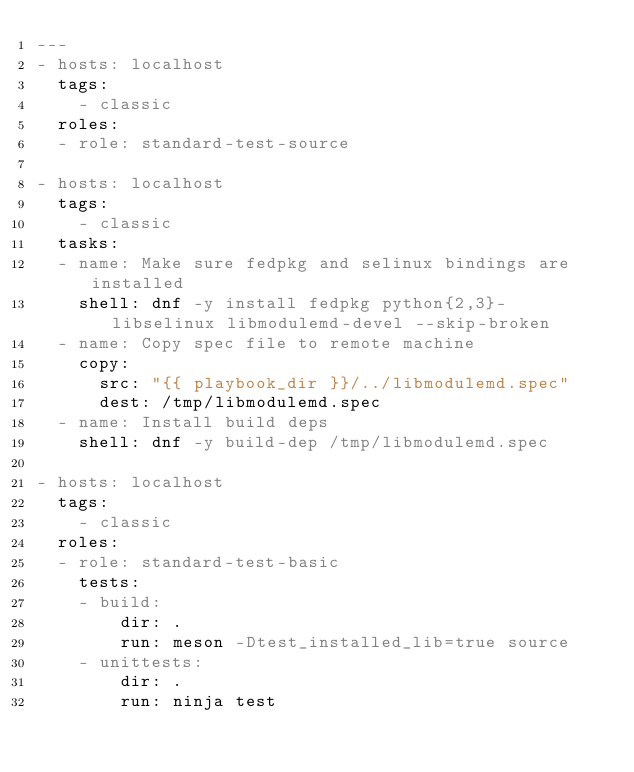<code> <loc_0><loc_0><loc_500><loc_500><_YAML_>---
- hosts: localhost
  tags:
    - classic
  roles:
  - role: standard-test-source

- hosts: localhost
  tags:
    - classic
  tasks:
  - name: Make sure fedpkg and selinux bindings are installed
    shell: dnf -y install fedpkg python{2,3}-libselinux libmodulemd-devel --skip-broken
  - name: Copy spec file to remote machine
    copy:
      src: "{{ playbook_dir }}/../libmodulemd.spec"
      dest: /tmp/libmodulemd.spec
  - name: Install build deps
    shell: dnf -y build-dep /tmp/libmodulemd.spec

- hosts: localhost
  tags:
    - classic
  roles:
  - role: standard-test-basic
    tests:
    - build:
        dir: .
        run: meson -Dtest_installed_lib=true source
    - unittests:
        dir: .
        run: ninja test
</code> 